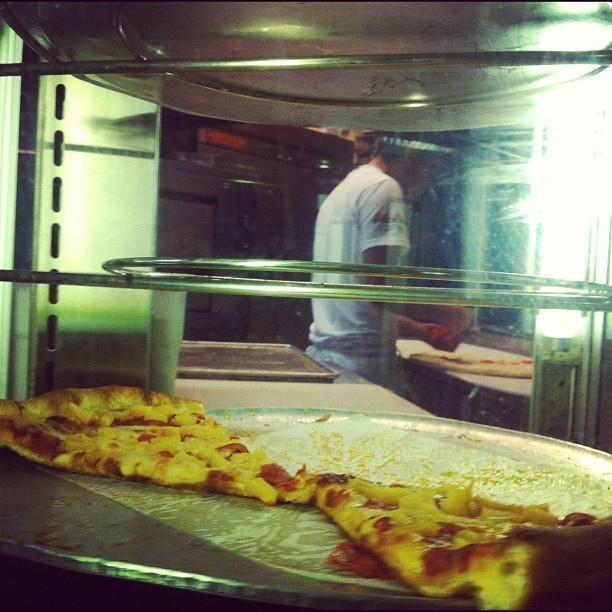How many pizzas are there?
Give a very brief answer. 2. How many birds are in the photo?
Give a very brief answer. 0. 